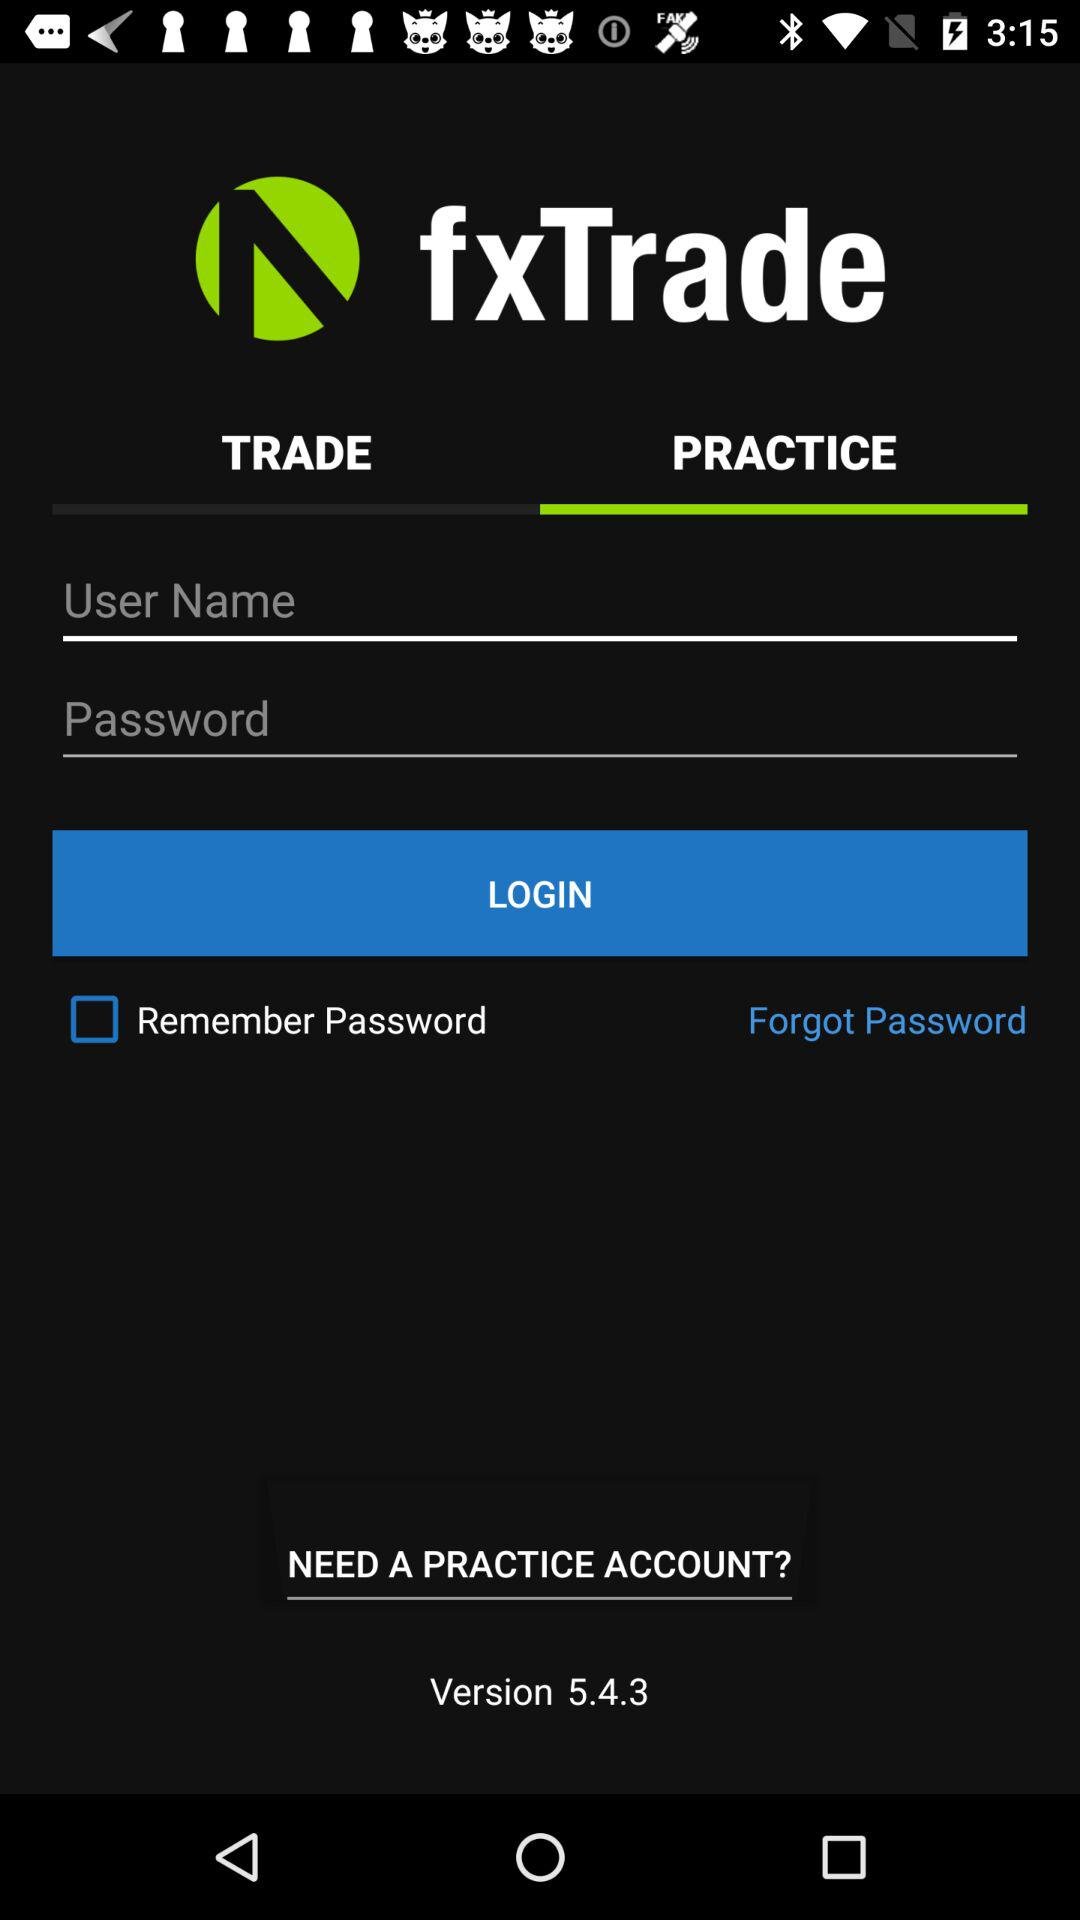What is the application name? The application name is "fxTrade". 